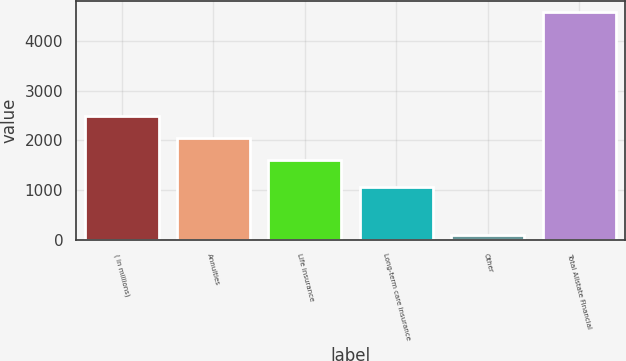Convert chart to OTSL. <chart><loc_0><loc_0><loc_500><loc_500><bar_chart><fcel>( in millions)<fcel>Annuities<fcel>Life insurance<fcel>Long-term care insurance<fcel>Other<fcel>Total Allstate Financial<nl><fcel>2498<fcel>2049<fcel>1600<fcel>1063<fcel>87<fcel>4577<nl></chart> 